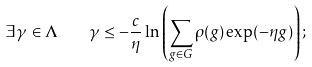Convert formula to latex. <formula><loc_0><loc_0><loc_500><loc_500>\exists \gamma \in \Lambda \quad \gamma \leq - \frac { c } { \eta } \ln \left ( \sum _ { g \in G } \rho ( g ) \exp ( - \eta g ) \right ) ;</formula> 